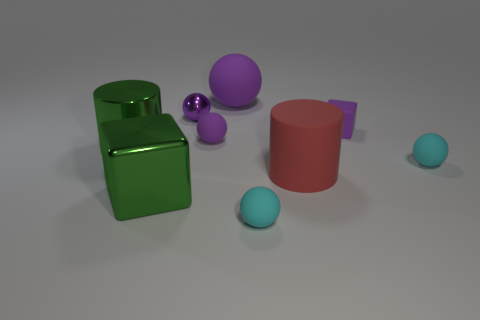How many other things are there of the same shape as the small metallic object?
Offer a very short reply. 4. There is a tiny thing that is in front of the big green thing in front of the large rubber thing that is right of the big purple object; what color is it?
Give a very brief answer. Cyan. How many big spheres are there?
Your answer should be very brief. 1. How many tiny objects are blocks or cyan objects?
Keep it short and to the point. 3. There is a metallic thing that is the same size as the purple cube; what is its shape?
Your response must be concise. Sphere. Are there any other things that are the same size as the purple matte block?
Offer a very short reply. Yes. What is the material of the big cylinder that is right of the small rubber thing that is to the left of the large purple object?
Offer a very short reply. Rubber. Does the red cylinder have the same size as the purple cube?
Offer a very short reply. No. How many things are either small cyan matte things in front of the red object or tiny cyan rubber blocks?
Your answer should be compact. 1. There is a thing in front of the block that is in front of the red thing; what shape is it?
Keep it short and to the point. Sphere. 